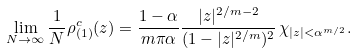<formula> <loc_0><loc_0><loc_500><loc_500>\lim _ { N \to \infty } \frac { 1 } { N } \rho _ { ( 1 ) } ^ { c } ( z ) = \frac { 1 - \alpha } { m \pi \alpha } \frac { | z | ^ { 2 / m - 2 } } { ( 1 - | z | ^ { 2 / m } ) ^ { 2 } } \, \chi _ { | z | < \alpha ^ { m / 2 } } .</formula> 